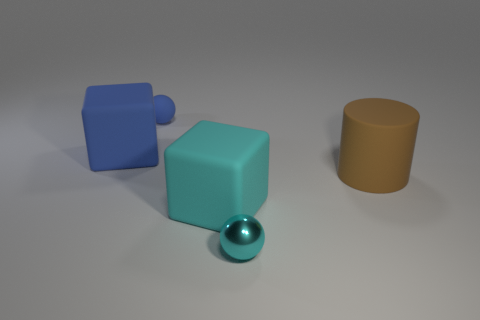Is the shape of the big blue rubber thing the same as the large cyan matte object?
Ensure brevity in your answer.  Yes. There is another small cyan thing that is the same shape as the tiny matte thing; what material is it?
Your answer should be compact. Metal. What is the color of the rubber thing that is both on the right side of the blue sphere and left of the cylinder?
Your response must be concise. Cyan. What is the color of the small metal ball?
Offer a terse response. Cyan. What is the material of the thing that is the same color as the rubber ball?
Your answer should be compact. Rubber. Is there a big cyan thing of the same shape as the big blue thing?
Ensure brevity in your answer.  Yes. What is the size of the block that is on the right side of the blue matte block?
Your answer should be very brief. Large. There is a cylinder that is the same size as the cyan matte object; what material is it?
Give a very brief answer. Rubber. Is the number of small blue rubber things greater than the number of blue things?
Your response must be concise. No. How big is the matte object that is right of the block that is to the right of the rubber ball?
Your response must be concise. Large. 